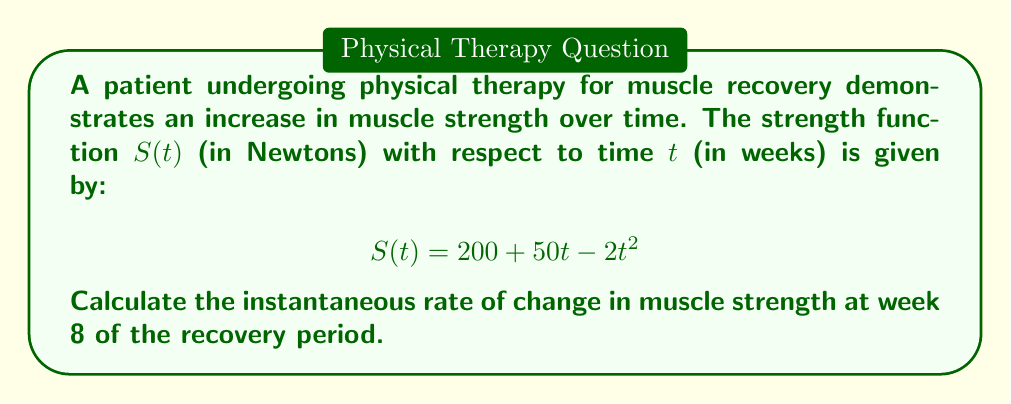Could you help me with this problem? To find the instantaneous rate of change in muscle strength at a specific point in time, we need to calculate the derivative of the strength function $S(t)$ and evaluate it at the given time.

1. First, let's find the derivative of $S(t)$:
   $$S(t) = 200 + 50t - 2t^2$$
   $$S'(t) = 50 - 4t$$

   This derivative represents the rate of change of muscle strength at any given time $t$.

2. Now, we need to evaluate $S'(t)$ at $t = 8$ weeks:
   $$S'(8) = 50 - 4(8)$$
   $$S'(8) = 50 - 32$$
   $$S'(8) = 18$$

3. Interpret the result:
   The instantaneous rate of change at week 8 is 18 Newtons per week. This positive value indicates that the muscle strength is still increasing at this point, but at a slower rate than initially.

4. Note on the function behavior:
   The negative coefficient of $t^2$ in the original function suggests that the rate of strength increase will eventually slow down and potentially decrease. This aligns with typical recovery patterns where initial gains are rapid but then plateau.
Answer: The instantaneous rate of change in muscle strength at week 8 of the recovery period is 18 Newtons per week. 